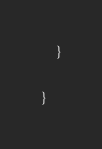<code> <loc_0><loc_0><loc_500><loc_500><_Java_>	}

}
</code> 